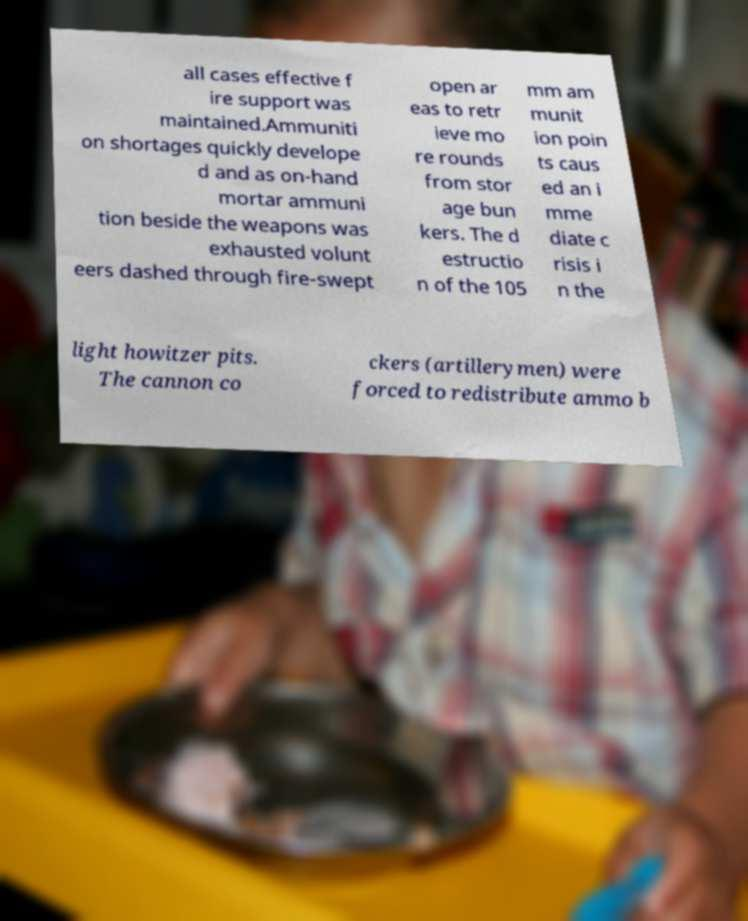For documentation purposes, I need the text within this image transcribed. Could you provide that? all cases effective f ire support was maintained.Ammuniti on shortages quickly develope d and as on-hand mortar ammuni tion beside the weapons was exhausted volunt eers dashed through fire-swept open ar eas to retr ieve mo re rounds from stor age bun kers. The d estructio n of the 105 mm am munit ion poin ts caus ed an i mme diate c risis i n the light howitzer pits. The cannon co ckers (artillerymen) were forced to redistribute ammo b 